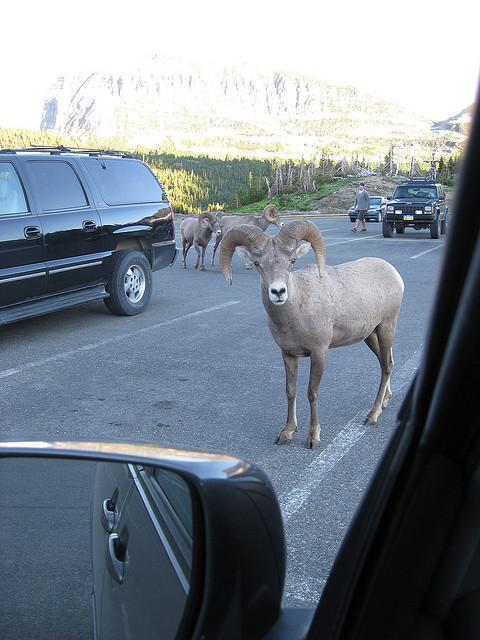How many cars have zebra stripes?
Give a very brief answer. 0. 